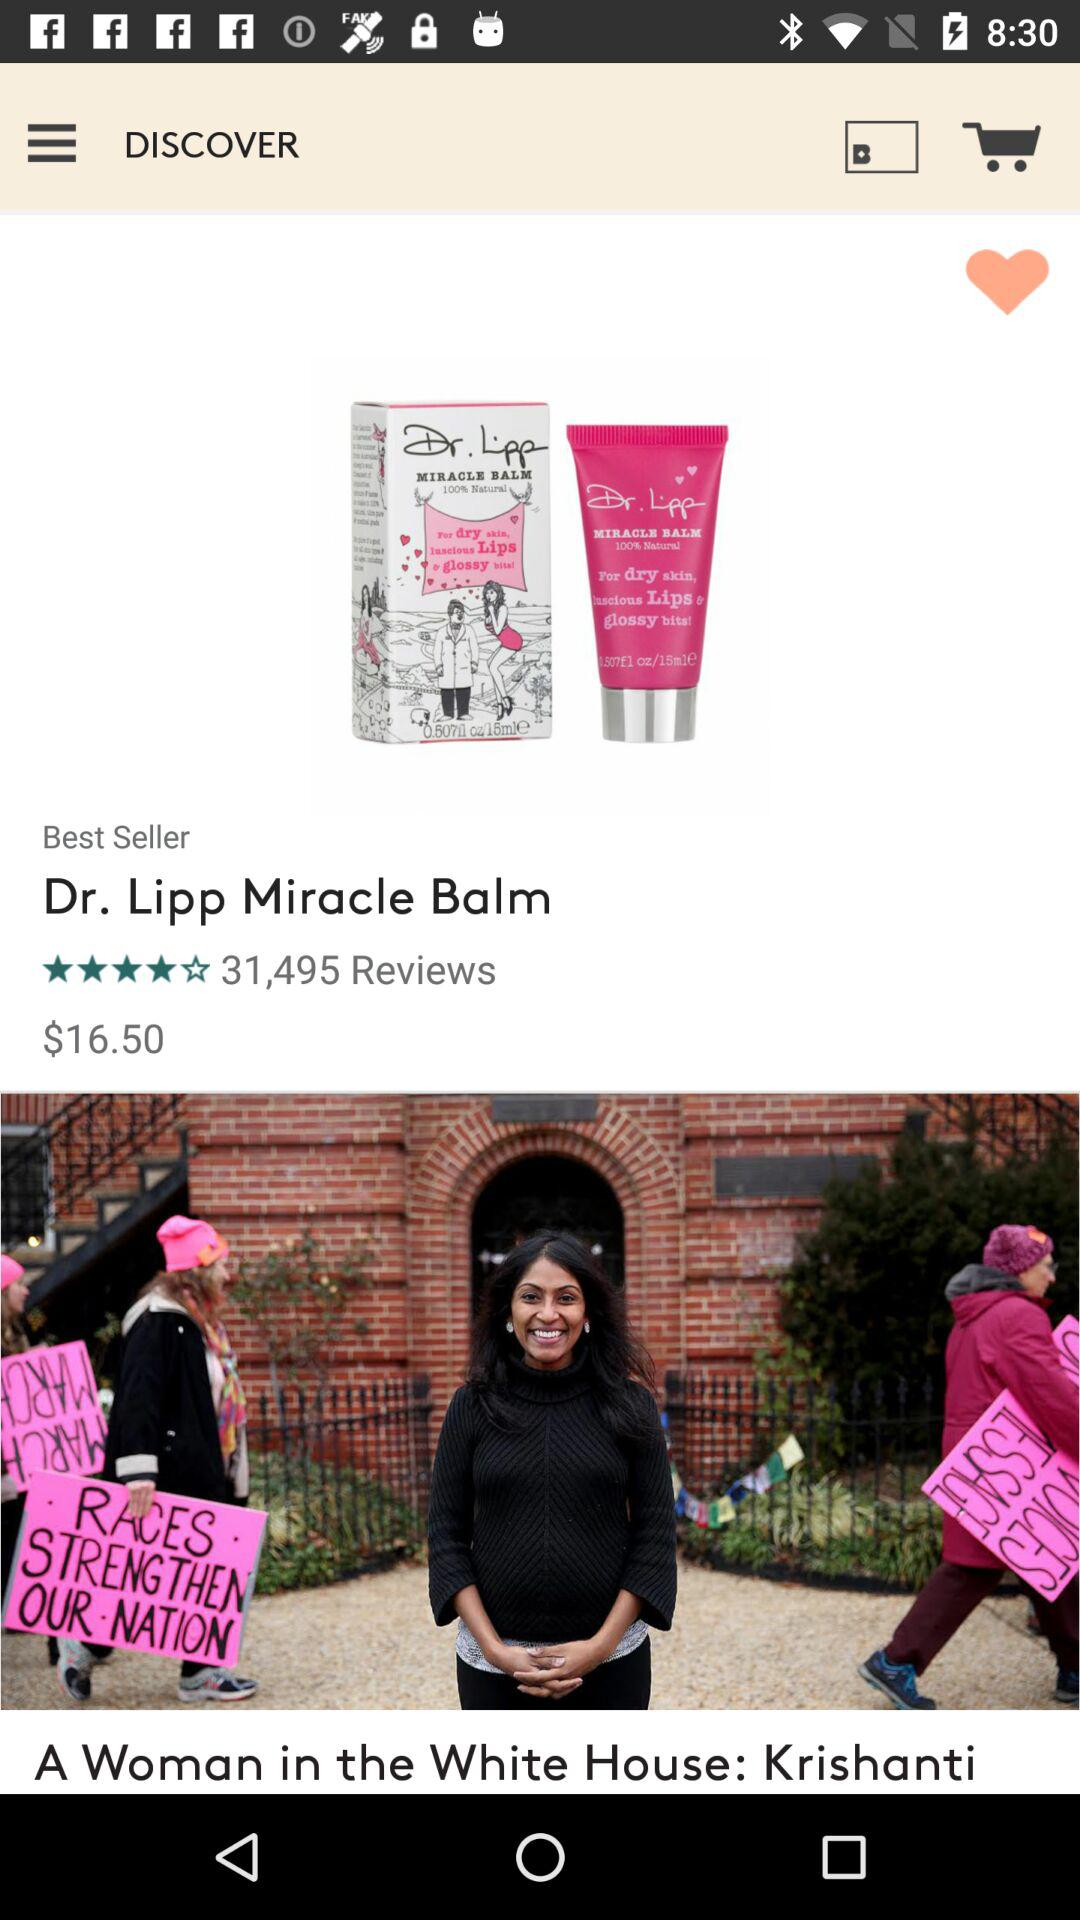How many reviews are there? There are 31,495 reviews. 